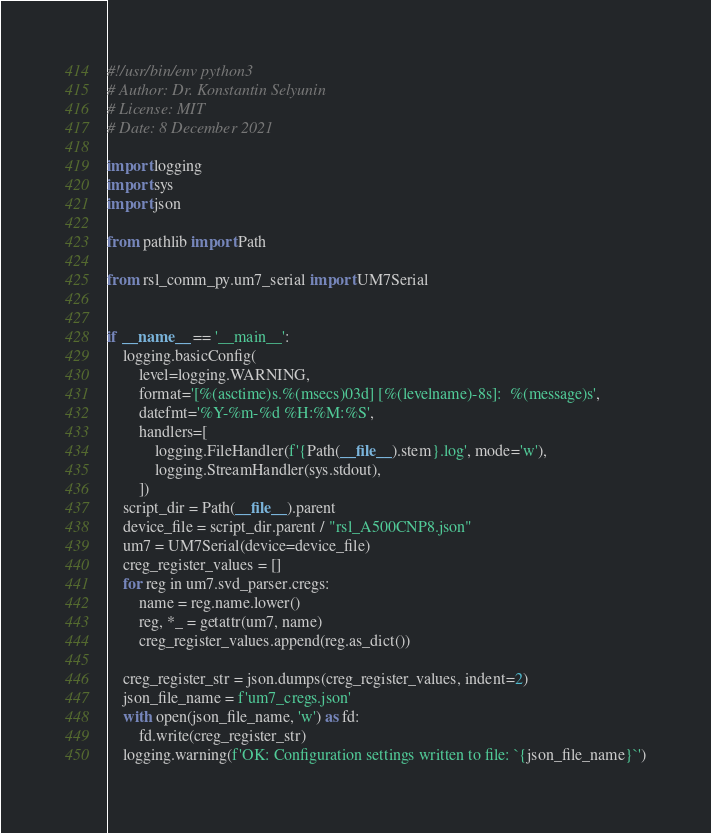Convert code to text. <code><loc_0><loc_0><loc_500><loc_500><_Python_>#!/usr/bin/env python3
# Author: Dr. Konstantin Selyunin
# License: MIT
# Date: 8 December 2021

import logging
import sys
import json

from pathlib import Path

from rsl_comm_py.um7_serial import UM7Serial


if __name__ == '__main__':
    logging.basicConfig(
        level=logging.WARNING,
        format='[%(asctime)s.%(msecs)03d] [%(levelname)-8s]:  %(message)s',
        datefmt='%Y-%m-%d %H:%M:%S',
        handlers=[
            logging.FileHandler(f'{Path(__file__).stem}.log', mode='w'),
            logging.StreamHandler(sys.stdout),
        ])
    script_dir = Path(__file__).parent
    device_file = script_dir.parent / "rsl_A500CNP8.json"
    um7 = UM7Serial(device=device_file)
    creg_register_values = []
    for reg in um7.svd_parser.cregs:
        name = reg.name.lower()
        reg, *_ = getattr(um7, name)
        creg_register_values.append(reg.as_dict())

    creg_register_str = json.dumps(creg_register_values, indent=2)
    json_file_name = f'um7_cregs.json'
    with open(json_file_name, 'w') as fd:
        fd.write(creg_register_str)
    logging.warning(f'OK: Configuration settings written to file: `{json_file_name}`')
</code> 